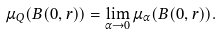<formula> <loc_0><loc_0><loc_500><loc_500>\mu _ { Q } ( B ( 0 , r ) ) = \lim _ { \alpha \to 0 } \mu _ { \alpha } ( B ( 0 , r ) ) .</formula> 